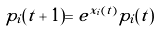<formula> <loc_0><loc_0><loc_500><loc_500>p _ { i } ( t + 1 ) = e ^ { x _ { i } ( t ) } p _ { i } ( t )</formula> 